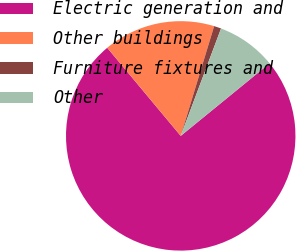Convert chart. <chart><loc_0><loc_0><loc_500><loc_500><pie_chart><fcel>Electric generation and<fcel>Other buildings<fcel>Furniture fixtures and<fcel>Other<nl><fcel>74.82%<fcel>15.77%<fcel>1.01%<fcel>8.39%<nl></chart> 